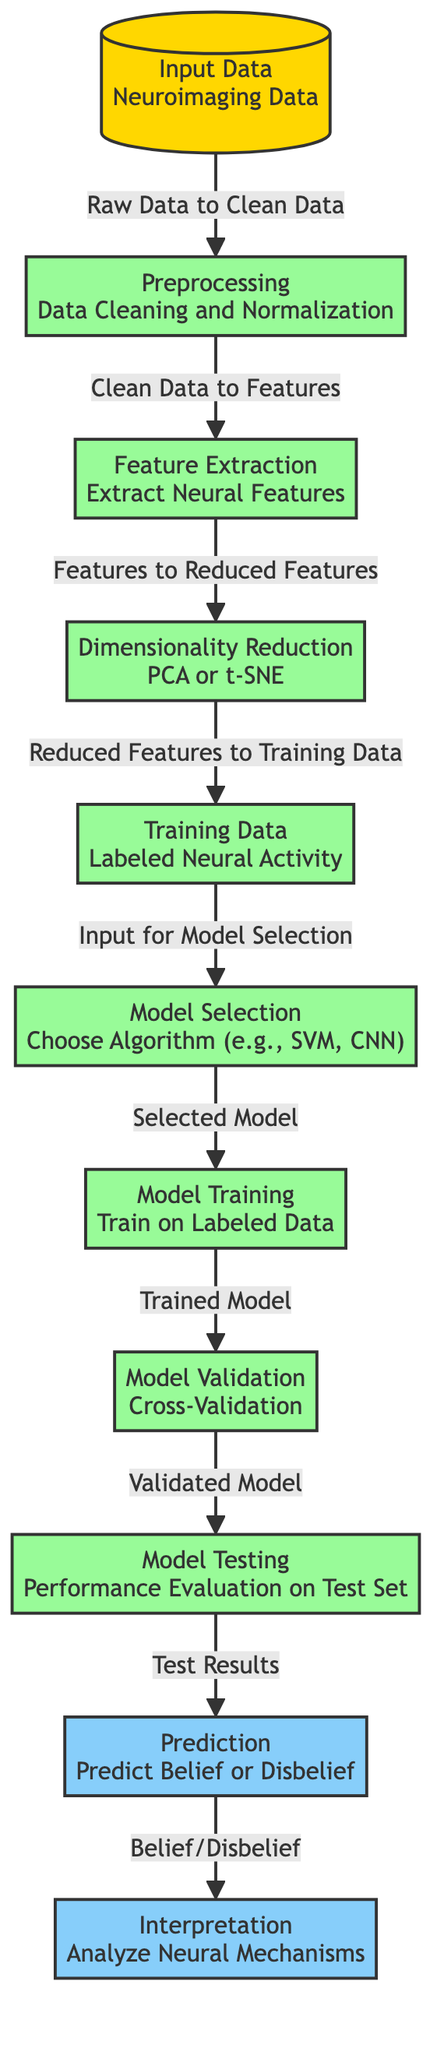What type of data is input into the model? The input data is neuroimaging data, as indicated by the label on the first node.
Answer: Neuroimaging Data What follows after preprocessing? After preprocessing, the next step is feature extraction, which is shown as the node directly connected to preprocessing.
Answer: Feature Extraction How many output stages are there in the diagram? There are two output stages: prediction and interpretation, which can be counted directly from the diagram.
Answer: 2 What is the purpose of the model validation step? The model validation step is used for cross-validation, which is specifically mentioned in the diagram under that node.
Answer: Cross-Validation Which node comes after training data? The training data node is followed by the model selection node, as indicated by the directional flow in the diagram.
Answer: Model Selection What type of model can be chosen during model selection? The model selection mentions several algorithms, including SVM and CNN, indicating the types of models available for choice.
Answer: SVM, CNN What is the final output of the predictive model? The final output of the predictive model is the prediction of belief or disbelief, as labeled in the diagram.
Answer: Predict Belief or Disbelief In which step do we analyze neural mechanisms? The analysis of neural mechanisms takes place in the interpretation step, which comes after the prediction step.
Answer: Interpretation How is performance evaluated on the test set? Performance on the test set is evaluated during the model testing stage, as shown in the diagram, which follows model validation.
Answer: Performance Evaluation 